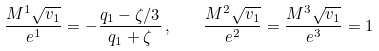Convert formula to latex. <formula><loc_0><loc_0><loc_500><loc_500>\frac { M ^ { 1 } \sqrt { v _ { 1 } } } { e ^ { 1 } } = - \frac { q _ { 1 } - \zeta / 3 } { q _ { 1 } + \zeta } \, , \quad \frac { M ^ { 2 } \sqrt { v _ { 1 } } } { e ^ { 2 } } = \frac { M ^ { 3 } \sqrt { v _ { 1 } } } { e ^ { 3 } } = 1</formula> 